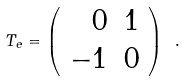<formula> <loc_0><loc_0><loc_500><loc_500>T _ { e } = \left ( \begin{array} { r r } { 0 } & { 1 } \\ { - 1 } & { 0 } \end{array} \right ) \ .</formula> 